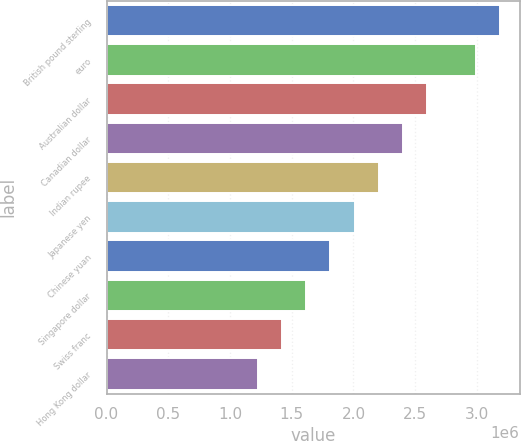<chart> <loc_0><loc_0><loc_500><loc_500><bar_chart><fcel>British pound sterling<fcel>euro<fcel>Australian dollar<fcel>Canadian dollar<fcel>Indian rupee<fcel>Japanese yen<fcel>Chinese yuan<fcel>Singapore dollar<fcel>Swiss franc<fcel>Hong Kong dollar<nl><fcel>3.18594e+06<fcel>2.98974e+06<fcel>2.59736e+06<fcel>2.40116e+06<fcel>2.20497e+06<fcel>2.00878e+06<fcel>1.81258e+06<fcel>1.61639e+06<fcel>1.4202e+06<fcel>1.224e+06<nl></chart> 